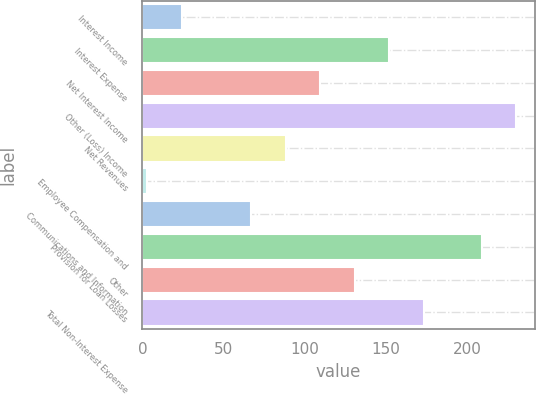Convert chart to OTSL. <chart><loc_0><loc_0><loc_500><loc_500><bar_chart><fcel>Interest Income<fcel>Interest Expense<fcel>Net Interest Income<fcel>Other (Loss) Income<fcel>Net Revenues<fcel>Employee Compensation and<fcel>Communications and Information<fcel>Provision for Loan Losses<fcel>Other<fcel>Total Non-Interest Expense<nl><fcel>24.3<fcel>152.1<fcel>109.5<fcel>230.3<fcel>88.2<fcel>3<fcel>66.9<fcel>209<fcel>130.8<fcel>173.4<nl></chart> 